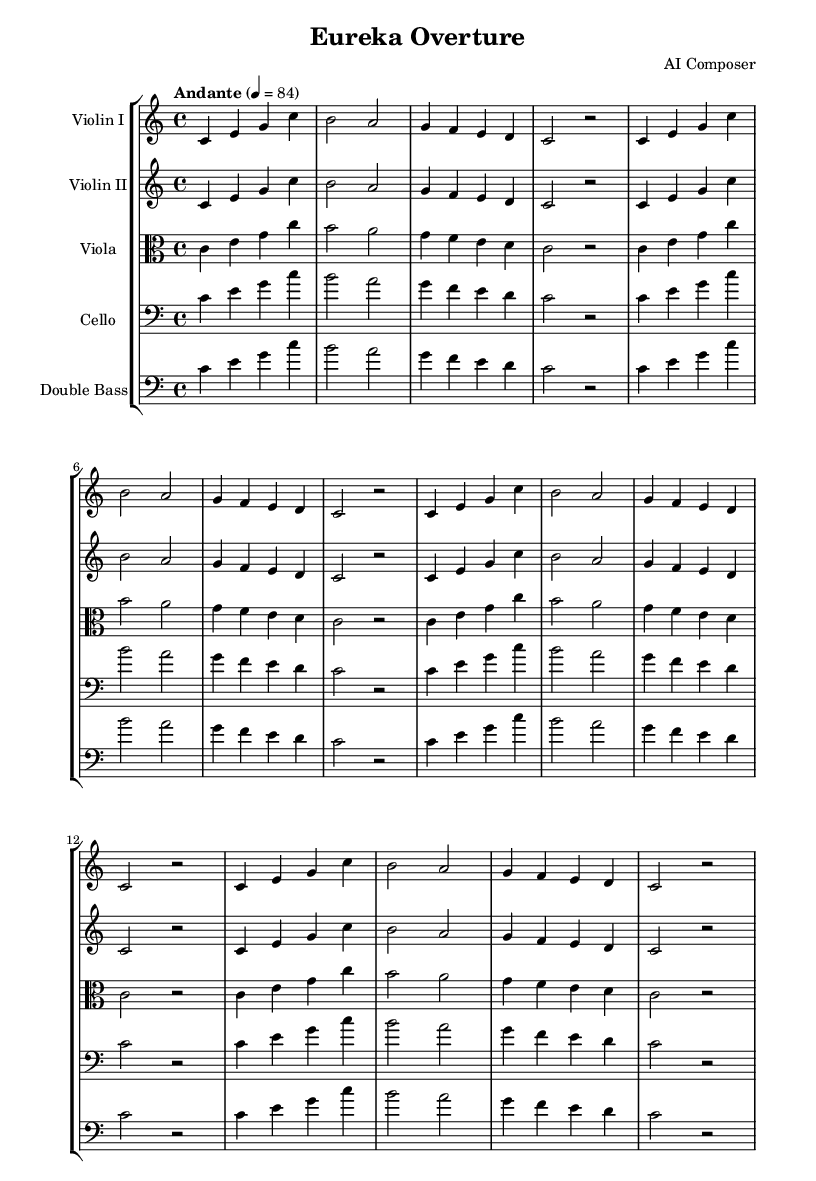What is the key signature of this music? The key signature is indicated at the beginning of the staff. Here, we can see that there are no sharps or flats shown, which denotes the key of C major.
Answer: C major What is the time signature of this music? The time signature is also shown at the beginning of the sheet music. It appears as 4/4, which tells us there are four beats in each measure and the quarter note gets one beat.
Answer: 4/4 What is the tempo marking for this piece? The tempo marking can be found above the staff, and it reads "Andante" with a metronome marking of 84, indicating a moderately slow pace for the music.
Answer: Andante, 84 How many measures are repeated in the violin part? By examining the sheet music, it's clear that the section labeled "repeat unfold 3" indicates that the prior four measures will be played three additional times, counting both the initial and repeated sections. Therefore, there are a total of four measures being repeated, but repeated three more times.
Answer: 4 What is the clef used for the viola part? The clef accompanying the viola in the score is labeled as "alto", which is a typical clef for the viola and indicates how the notes are read on the staff.
Answer: Alto Which instruments are included in this score? By observing the score, we note that it contains parts written for Violin I, Violin II, Viola, Cello, and Double Bass. Each instrument is listed separately, indicating their respective parts to be played.
Answer: Violin I, Violin II, Viola, Cello, Double Bass What is the phrase structure of the violin part? The violin part is organized into a clear phrase structure wherein each phrase consists of four measures, with the initial phrase followed by three repeated phrases as denoted by "repeat unfold 3". Each resultant section fits neatly into this framework, creating a sense of continuity and familiarity.
Answer: Four measures (with repeats) 